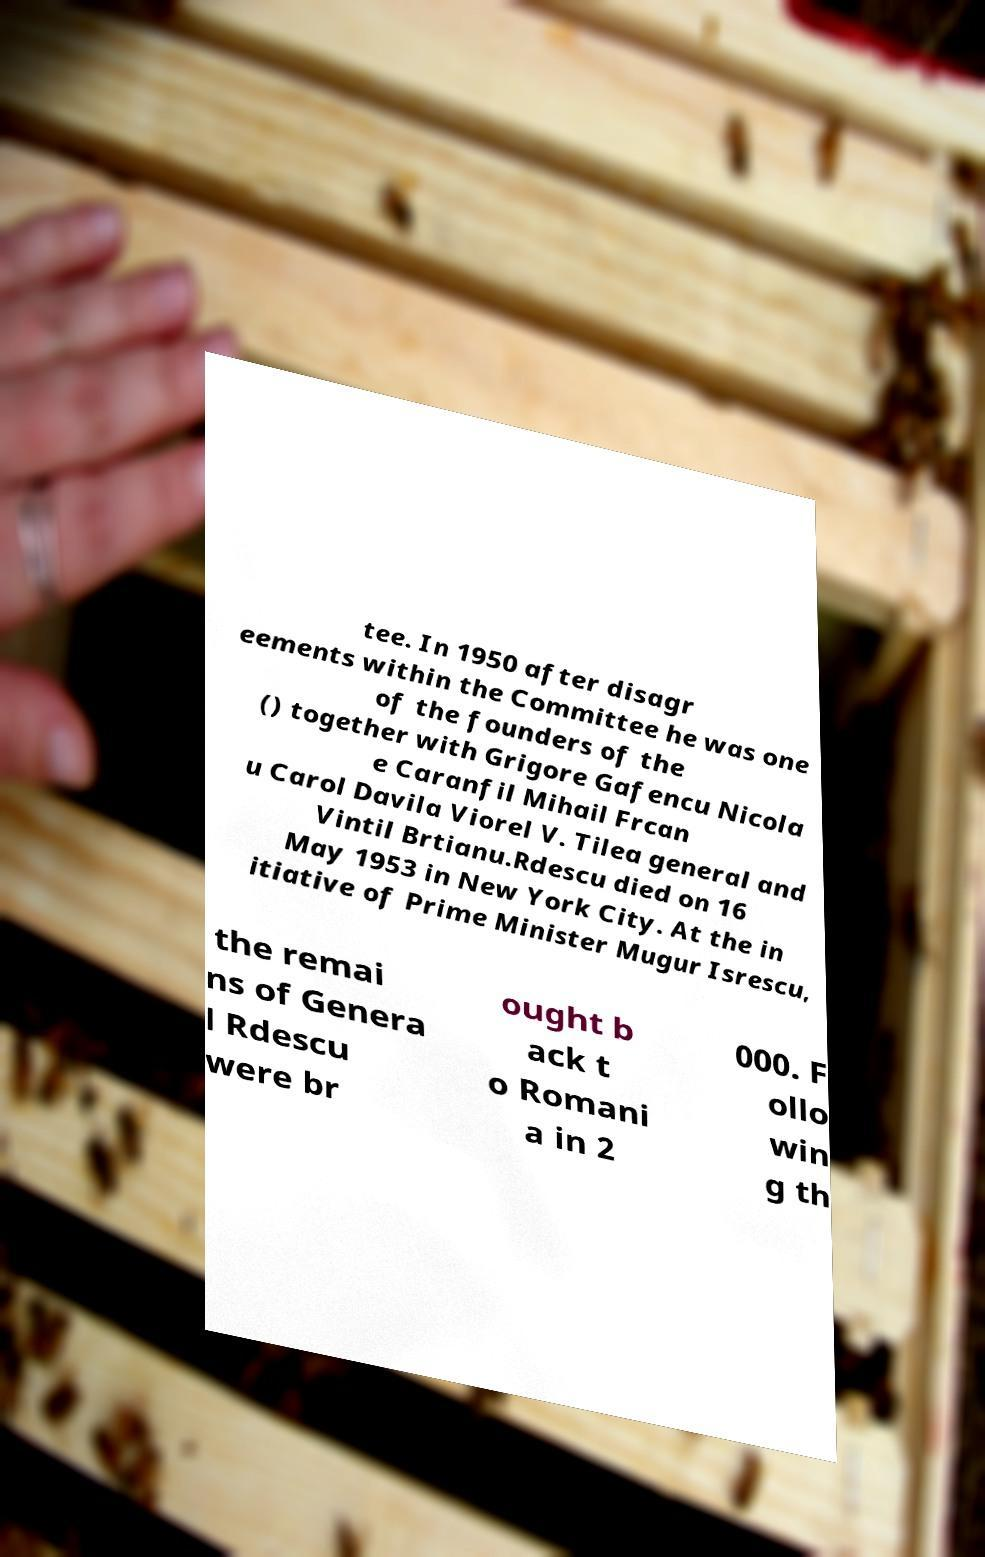What messages or text are displayed in this image? I need them in a readable, typed format. tee. In 1950 after disagr eements within the Committee he was one of the founders of the () together with Grigore Gafencu Nicola e Caranfil Mihail Frcan u Carol Davila Viorel V. Tilea general and Vintil Brtianu.Rdescu died on 16 May 1953 in New York City. At the in itiative of Prime Minister Mugur Isrescu, the remai ns of Genera l Rdescu were br ought b ack t o Romani a in 2 000. F ollo win g th 